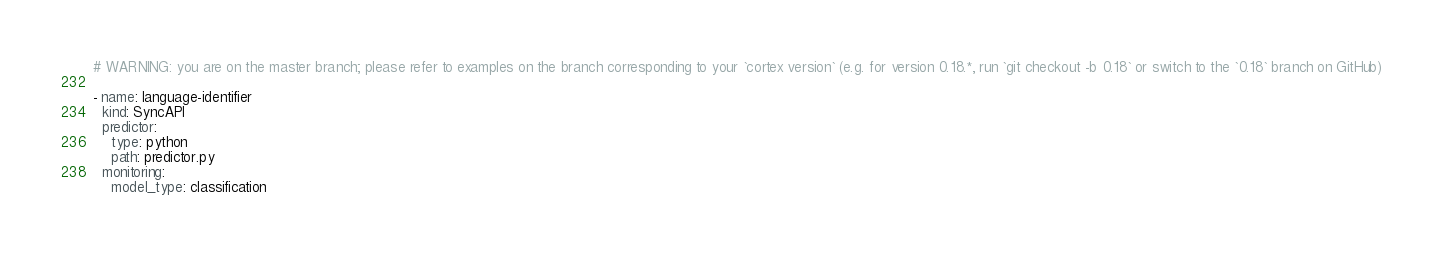Convert code to text. <code><loc_0><loc_0><loc_500><loc_500><_YAML_># WARNING: you are on the master branch; please refer to examples on the branch corresponding to your `cortex version` (e.g. for version 0.18.*, run `git checkout -b 0.18` or switch to the `0.18` branch on GitHub)

- name: language-identifier
  kind: SyncAPI
  predictor:
    type: python
    path: predictor.py
  monitoring:
    model_type: classification
</code> 